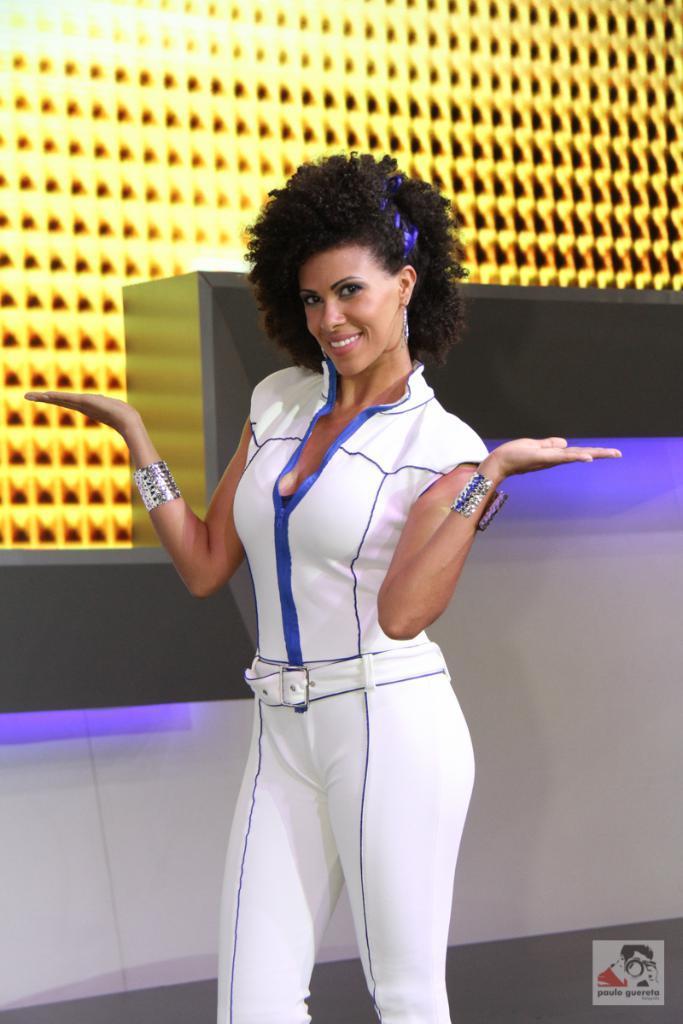Please provide a concise description of this image. In the center of the image we can see a lady standing. She is wearing a white dress. In the background there is a wall and we can see lights. 